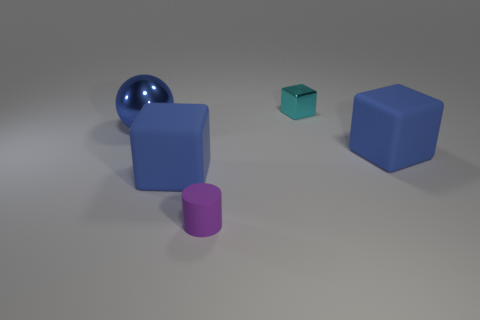Add 3 large brown metal cubes. How many objects exist? 8 Subtract all cylinders. How many objects are left? 4 Add 3 big brown metallic blocks. How many big brown metallic blocks exist? 3 Subtract 0 blue cylinders. How many objects are left? 5 Subtract all large things. Subtract all small cyan things. How many objects are left? 1 Add 3 tiny cyan shiny things. How many tiny cyan shiny things are left? 4 